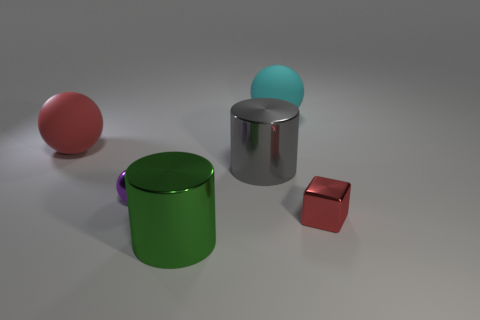Subtract all big balls. How many balls are left? 1 Subtract all purple spheres. How many spheres are left? 2 Add 1 large gray shiny cylinders. How many objects exist? 7 Subtract 1 cylinders. How many cylinders are left? 1 Subtract all blocks. How many objects are left? 5 Add 6 blocks. How many blocks exist? 7 Subtract 0 blue cubes. How many objects are left? 6 Subtract all purple blocks. Subtract all blue balls. How many blocks are left? 1 Subtract all big green matte cubes. Subtract all green shiny objects. How many objects are left? 5 Add 4 big red matte spheres. How many big red matte spheres are left? 5 